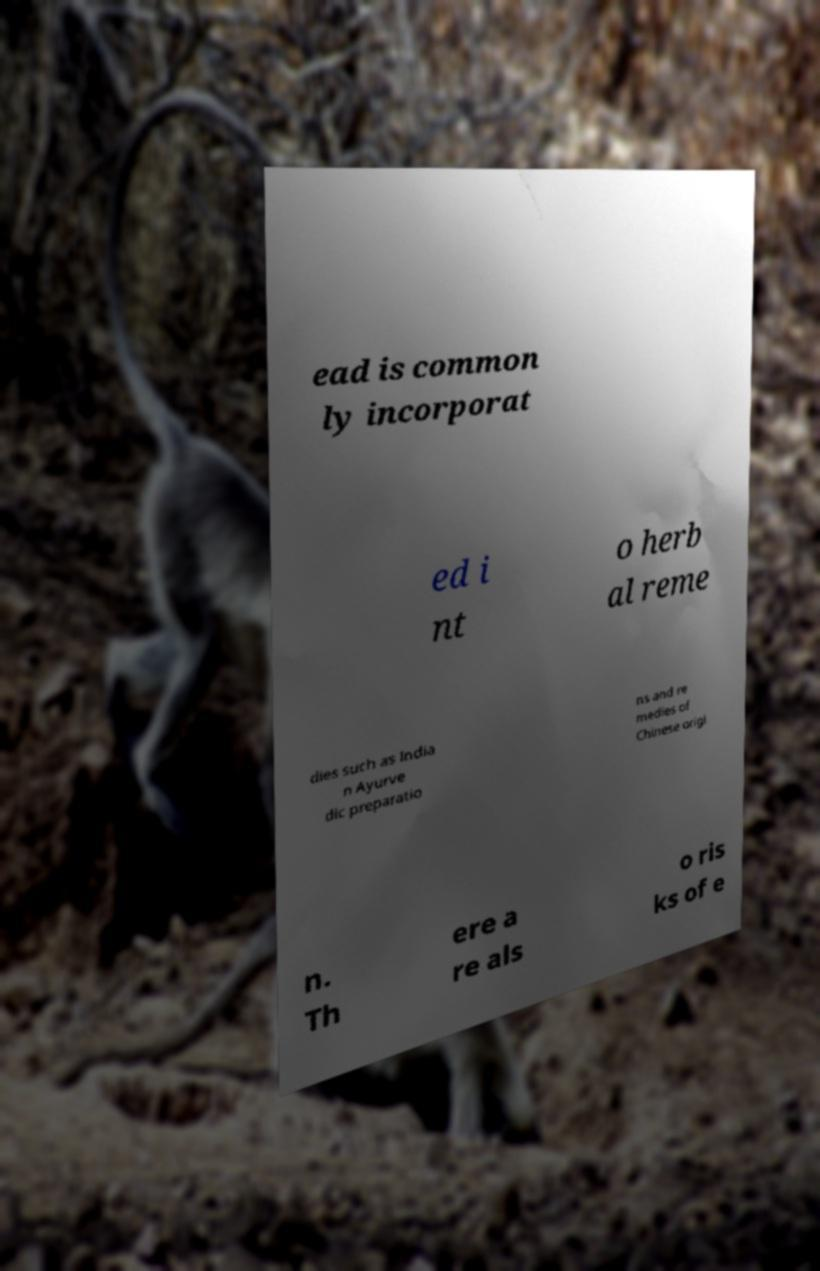For documentation purposes, I need the text within this image transcribed. Could you provide that? ead is common ly incorporat ed i nt o herb al reme dies such as India n Ayurve dic preparatio ns and re medies of Chinese origi n. Th ere a re als o ris ks of e 